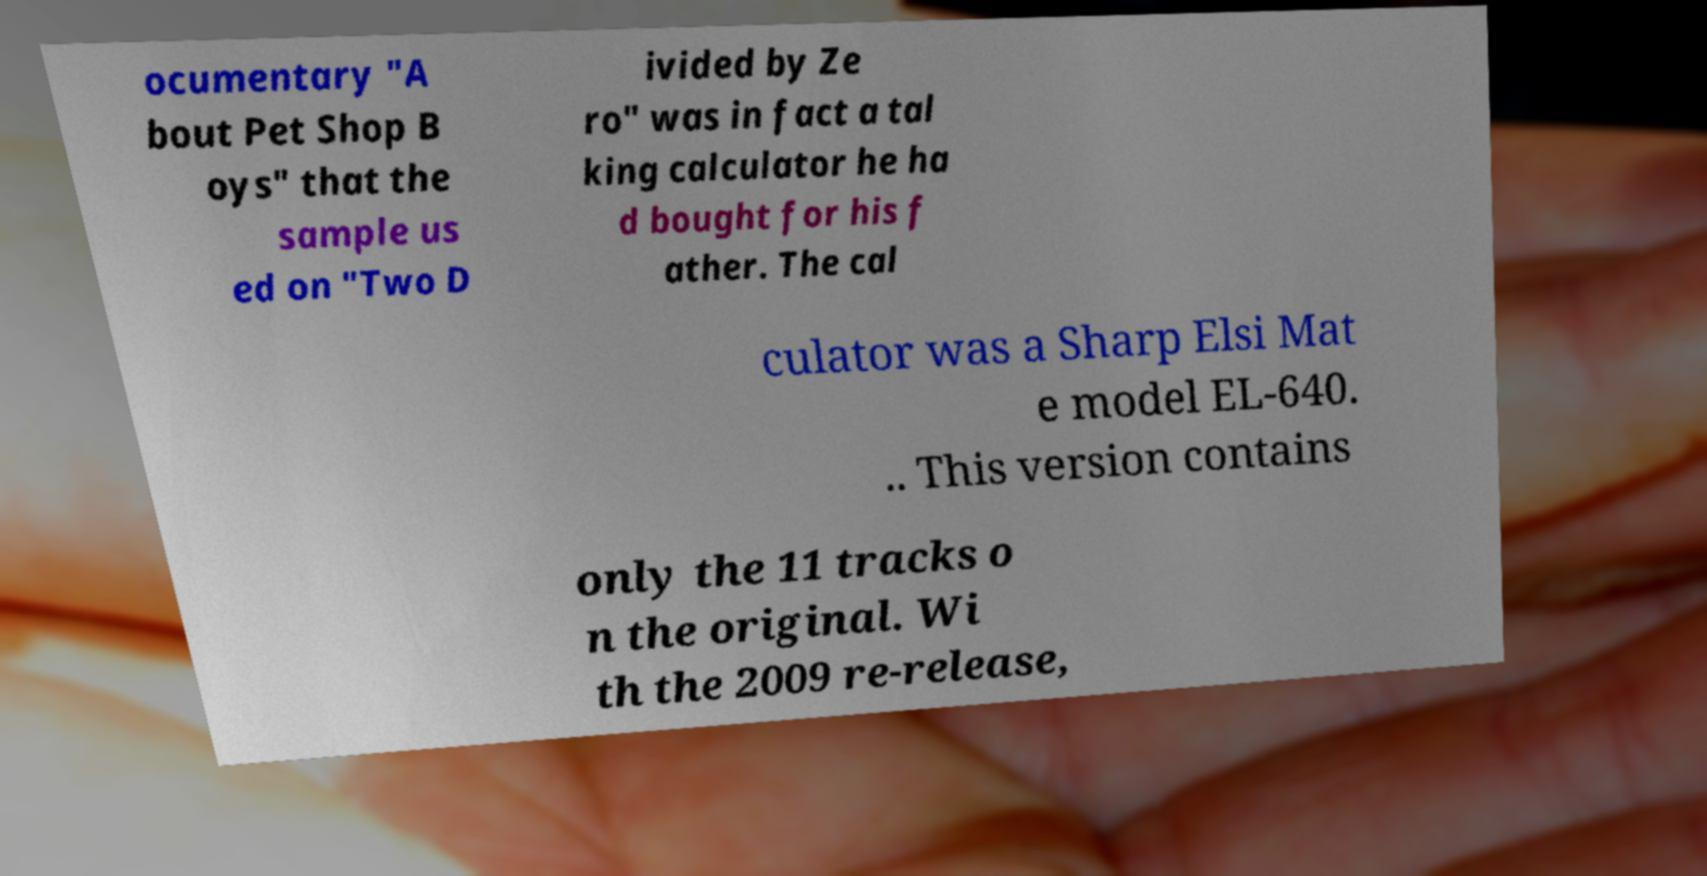There's text embedded in this image that I need extracted. Can you transcribe it verbatim? ocumentary "A bout Pet Shop B oys" that the sample us ed on "Two D ivided by Ze ro" was in fact a tal king calculator he ha d bought for his f ather. The cal culator was a Sharp Elsi Mat e model EL-640. .. This version contains only the 11 tracks o n the original. Wi th the 2009 re-release, 